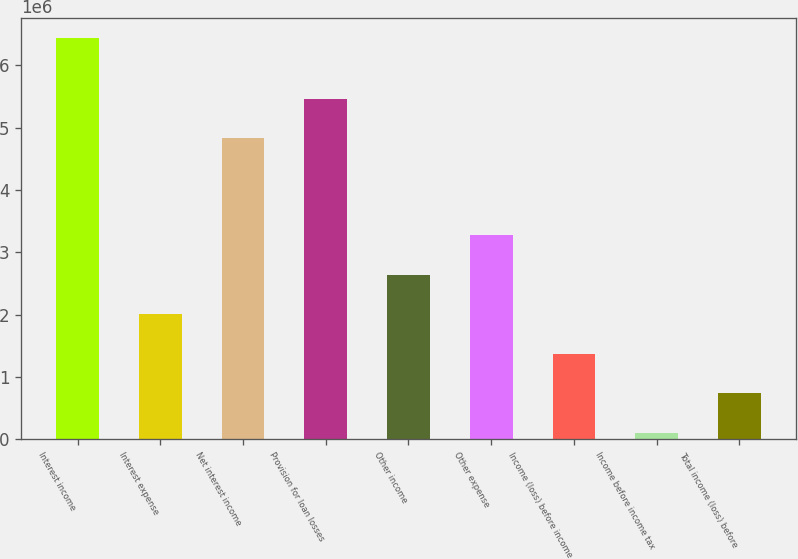<chart> <loc_0><loc_0><loc_500><loc_500><bar_chart><fcel>Interest income<fcel>Interest expense<fcel>Net interest income<fcel>Provision for loan losses<fcel>Other income<fcel>Other expense<fcel>Income (loss) before income<fcel>Income before income tax<fcel>Total income (loss) before<nl><fcel>6.43405e+06<fcel>2.0048e+06<fcel>4.82878e+06<fcel>5.46153e+06<fcel>2.63755e+06<fcel>3.2703e+06<fcel>1.37205e+06<fcel>106544<fcel>739295<nl></chart> 